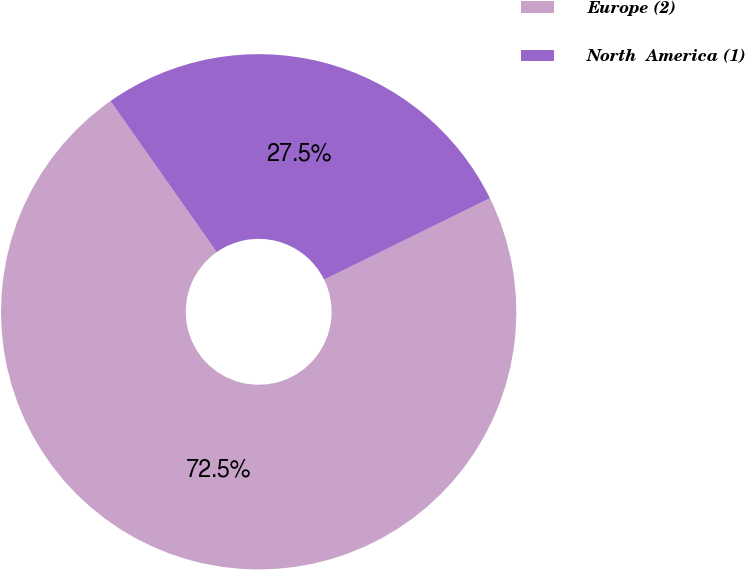Convert chart. <chart><loc_0><loc_0><loc_500><loc_500><pie_chart><fcel>Europe (2)<fcel>North  America (1)<nl><fcel>72.51%<fcel>27.49%<nl></chart> 